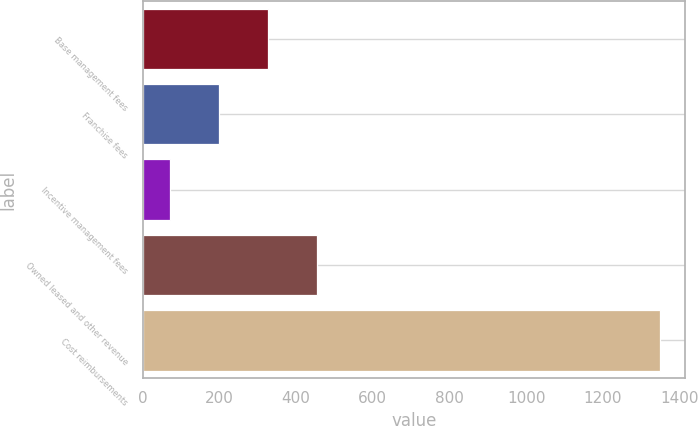Convert chart to OTSL. <chart><loc_0><loc_0><loc_500><loc_500><bar_chart><fcel>Base management fees<fcel>Franchise fees<fcel>Incentive management fees<fcel>Owned leased and other revenue<fcel>Cost reimbursements<nl><fcel>327.2<fcel>199.6<fcel>72<fcel>454.8<fcel>1348<nl></chart> 